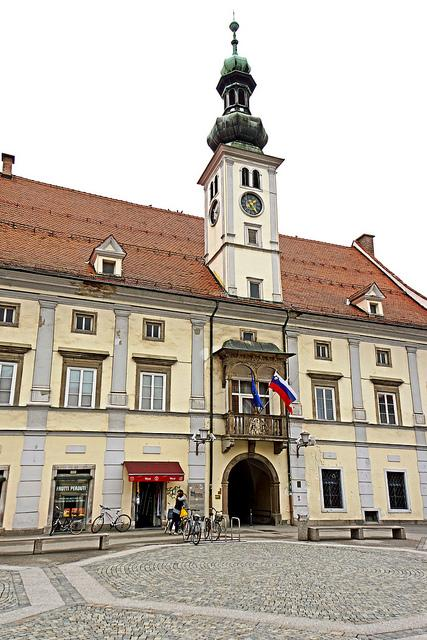What is under the clock tower? flags 